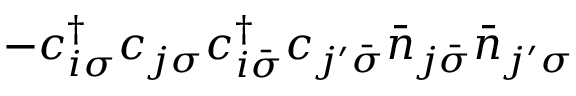Convert formula to latex. <formula><loc_0><loc_0><loc_500><loc_500>- c _ { i \sigma } ^ { \dagger } c _ { j \sigma } c _ { i \bar { \sigma } } ^ { \dagger } c _ { j ^ { \prime } \bar { \sigma } } \bar { n } _ { j \bar { \sigma } } \bar { n } _ { j ^ { \prime } \sigma }</formula> 